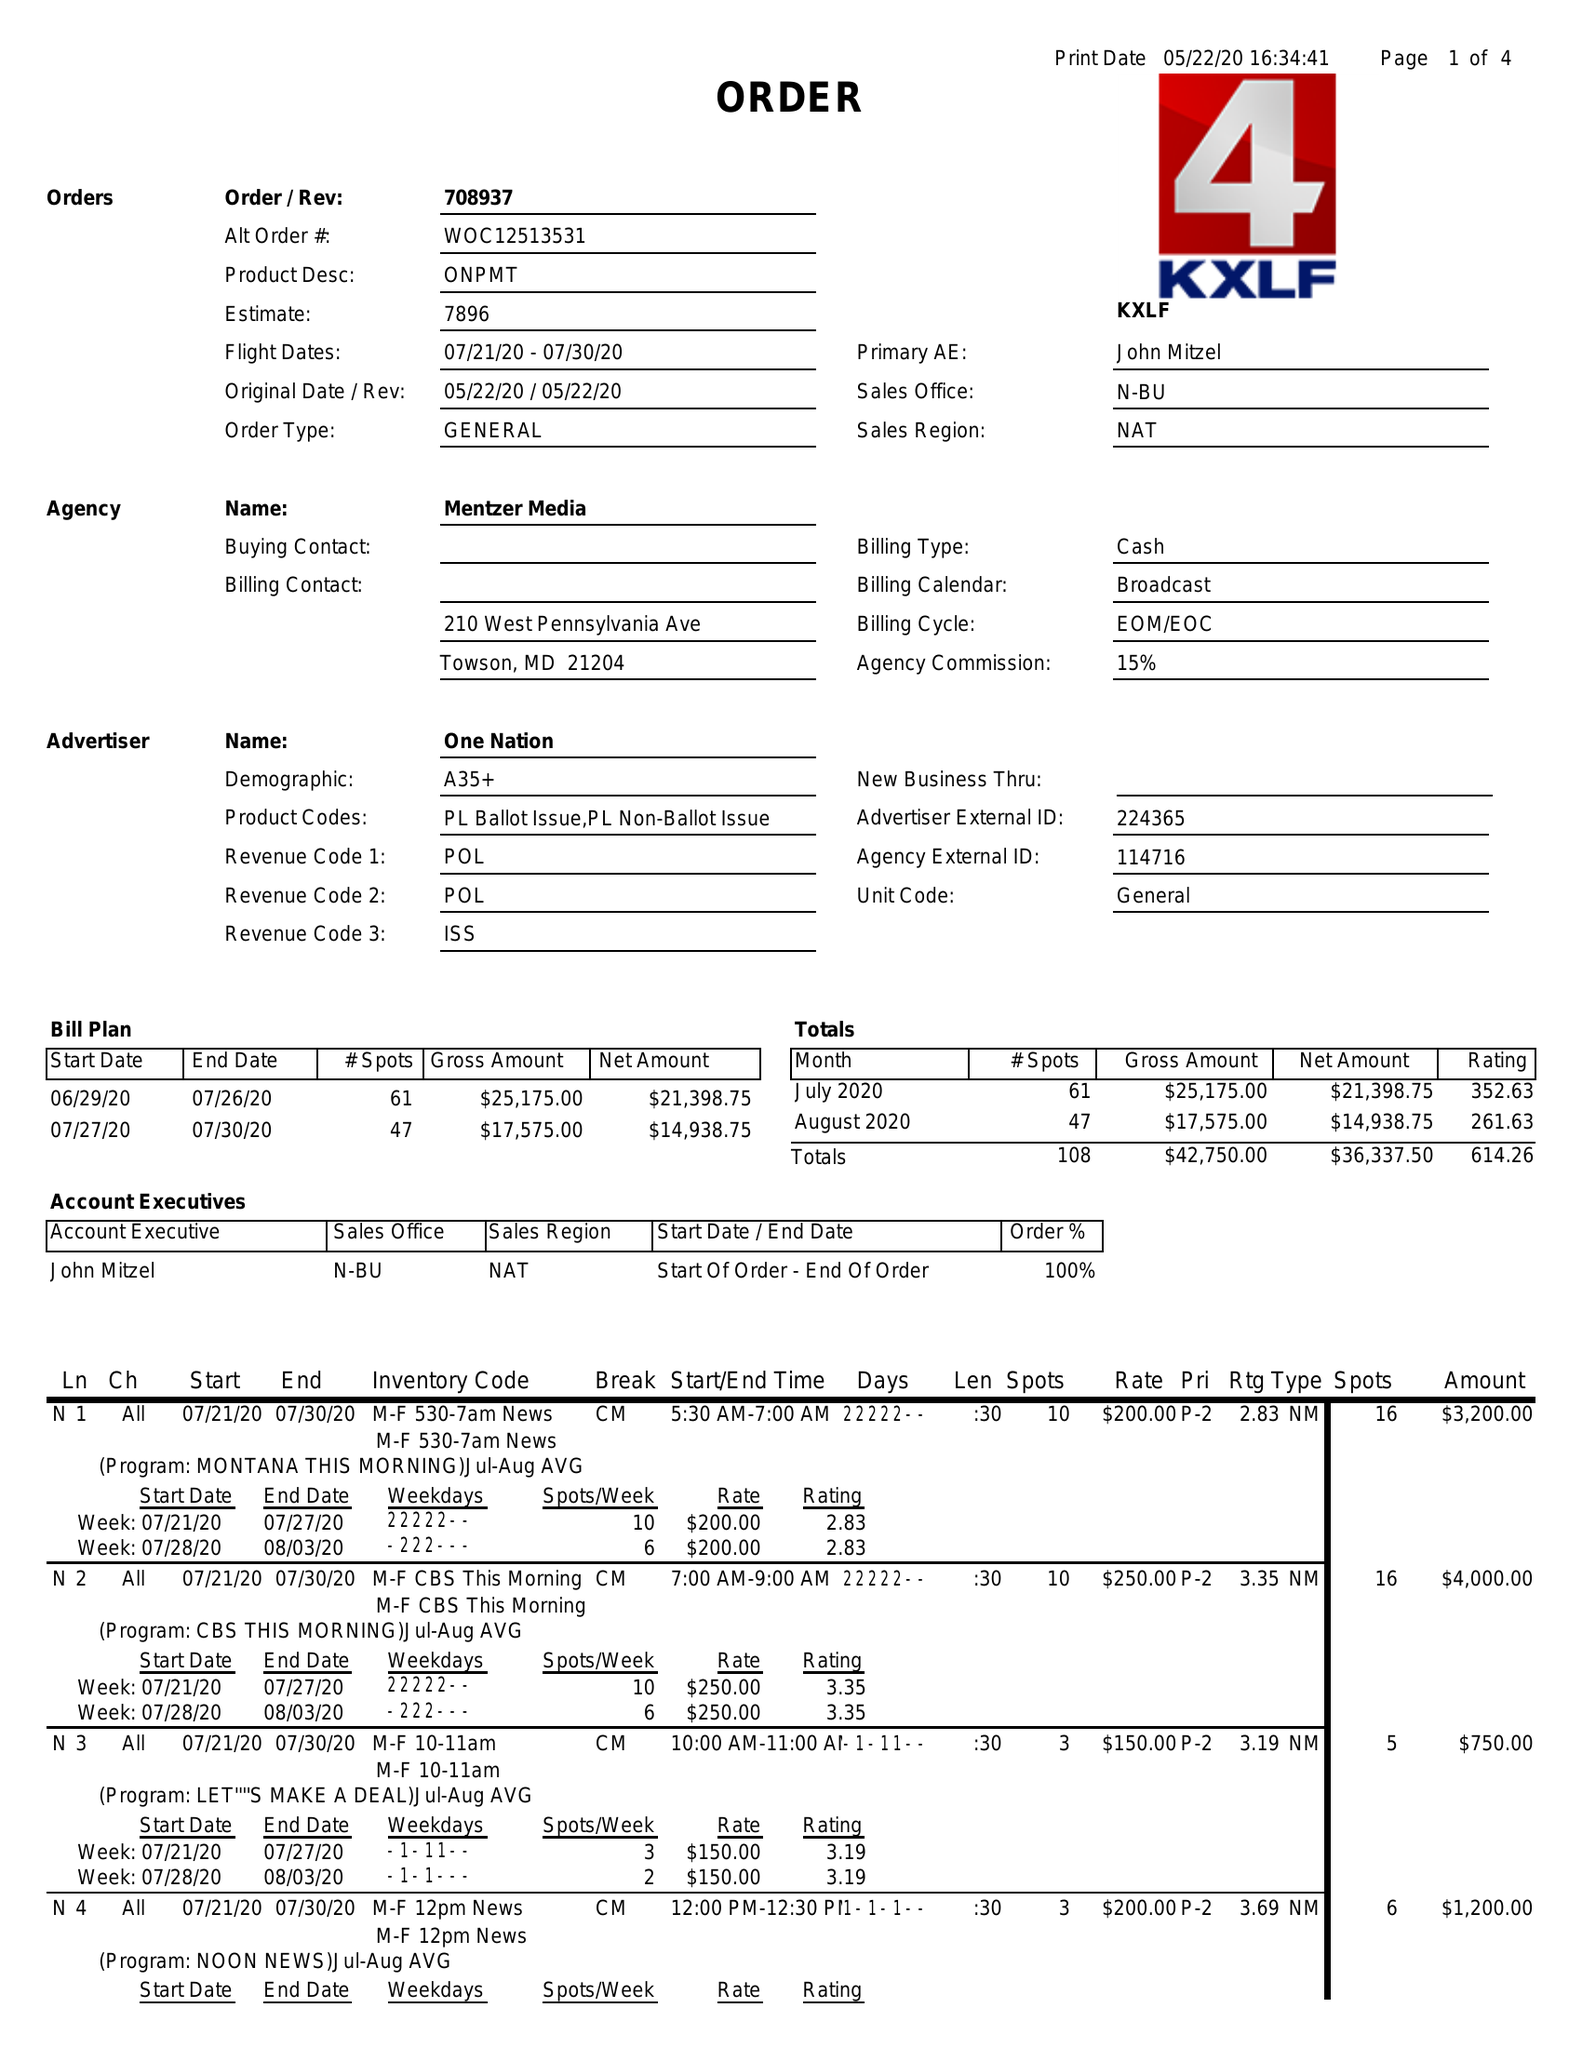What is the value for the gross_amount?
Answer the question using a single word or phrase. 42750.00 